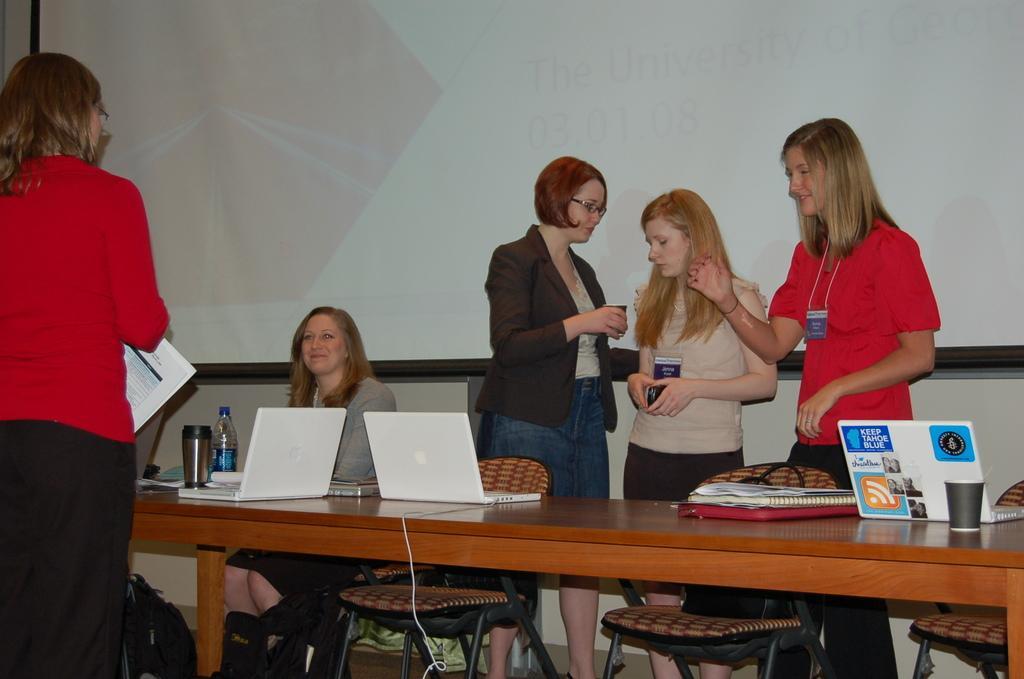Describe this image in one or two sentences. As we can see in the image, there is a screen and few people over here and in front of them there is a table. On table there are laptops, books and a glass. 